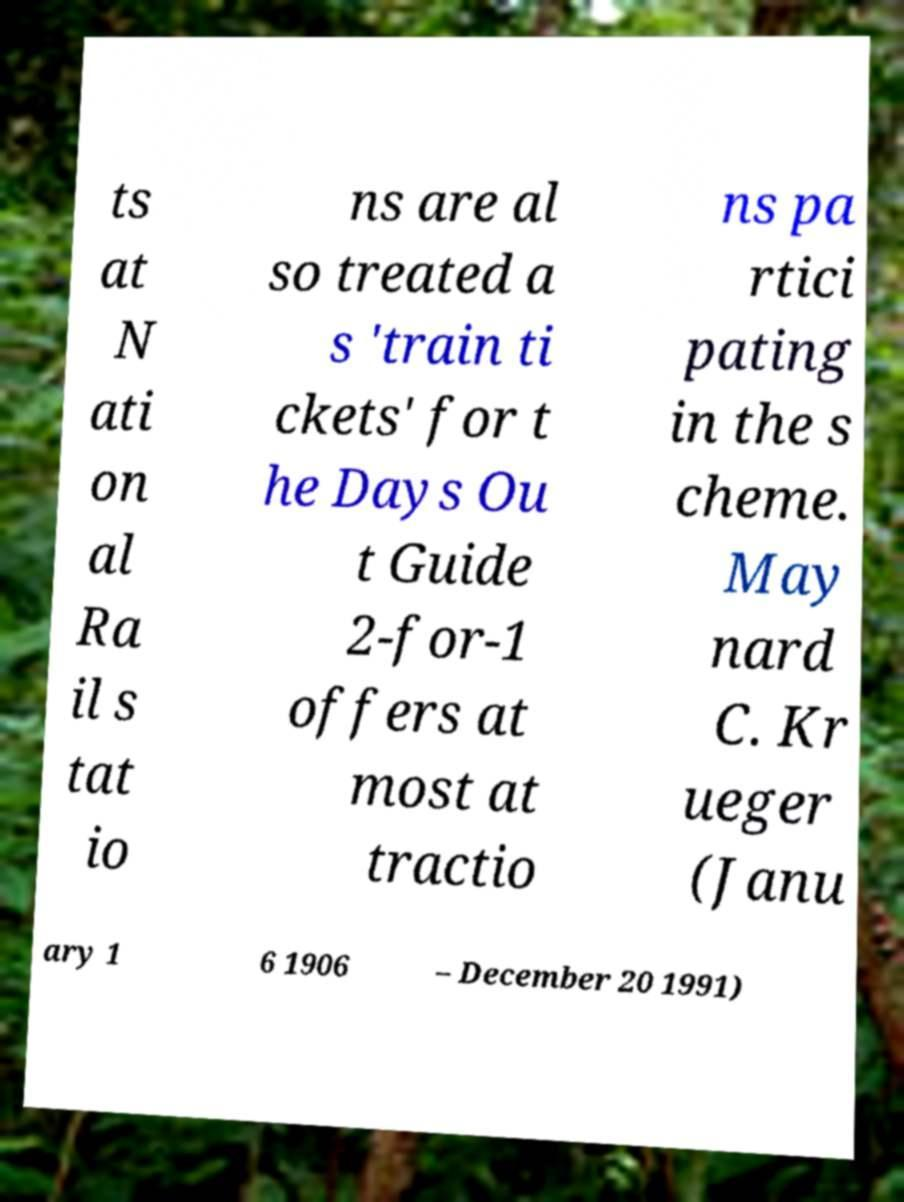Could you assist in decoding the text presented in this image and type it out clearly? ts at N ati on al Ra il s tat io ns are al so treated a s 'train ti ckets' for t he Days Ou t Guide 2-for-1 offers at most at tractio ns pa rtici pating in the s cheme. May nard C. Kr ueger (Janu ary 1 6 1906 – December 20 1991) 